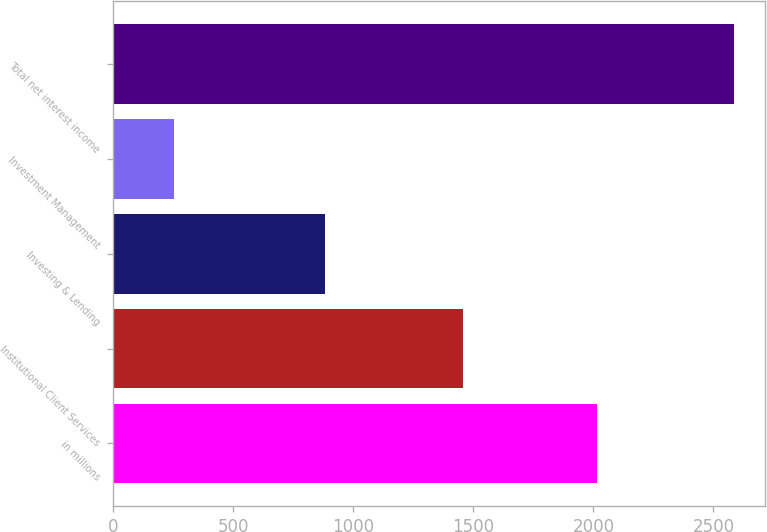Convert chart to OTSL. <chart><loc_0><loc_0><loc_500><loc_500><bar_chart><fcel>in millions<fcel>Institutional Client Services<fcel>Investing & Lending<fcel>Investment Management<fcel>Total net interest income<nl><fcel>2016<fcel>1456<fcel>880<fcel>251<fcel>2587<nl></chart> 